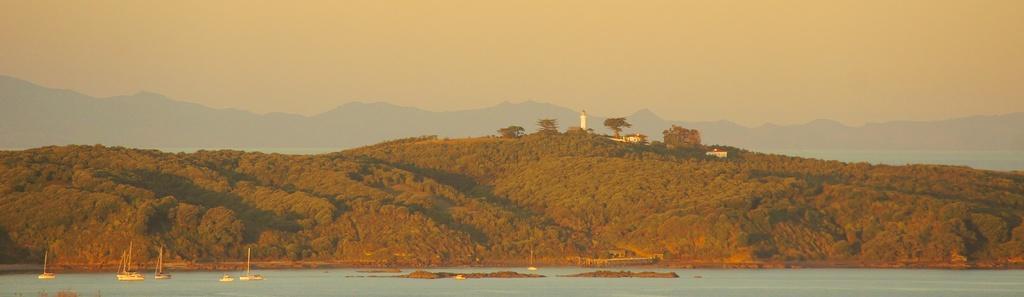How would you summarize this image in a sentence or two? At the bottom of the picture, we see water and we even see boats and yachts in the water. Beside that, there are many trees. We see buildings and a tower in the background and we even see the hills. At the top of the picture, we see the sky. 